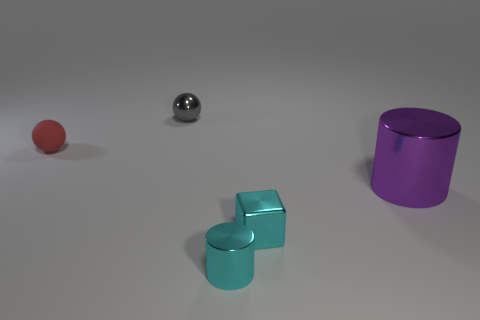Subtract all red balls. How many balls are left? 1 Add 3 large purple metallic cylinders. How many objects exist? 8 Subtract all cubes. How many objects are left? 4 Add 1 small red rubber balls. How many small red rubber balls are left? 2 Add 3 gray rubber things. How many gray rubber things exist? 3 Subtract 0 yellow cylinders. How many objects are left? 5 Subtract all cyan shiny objects. Subtract all cyan shiny things. How many objects are left? 1 